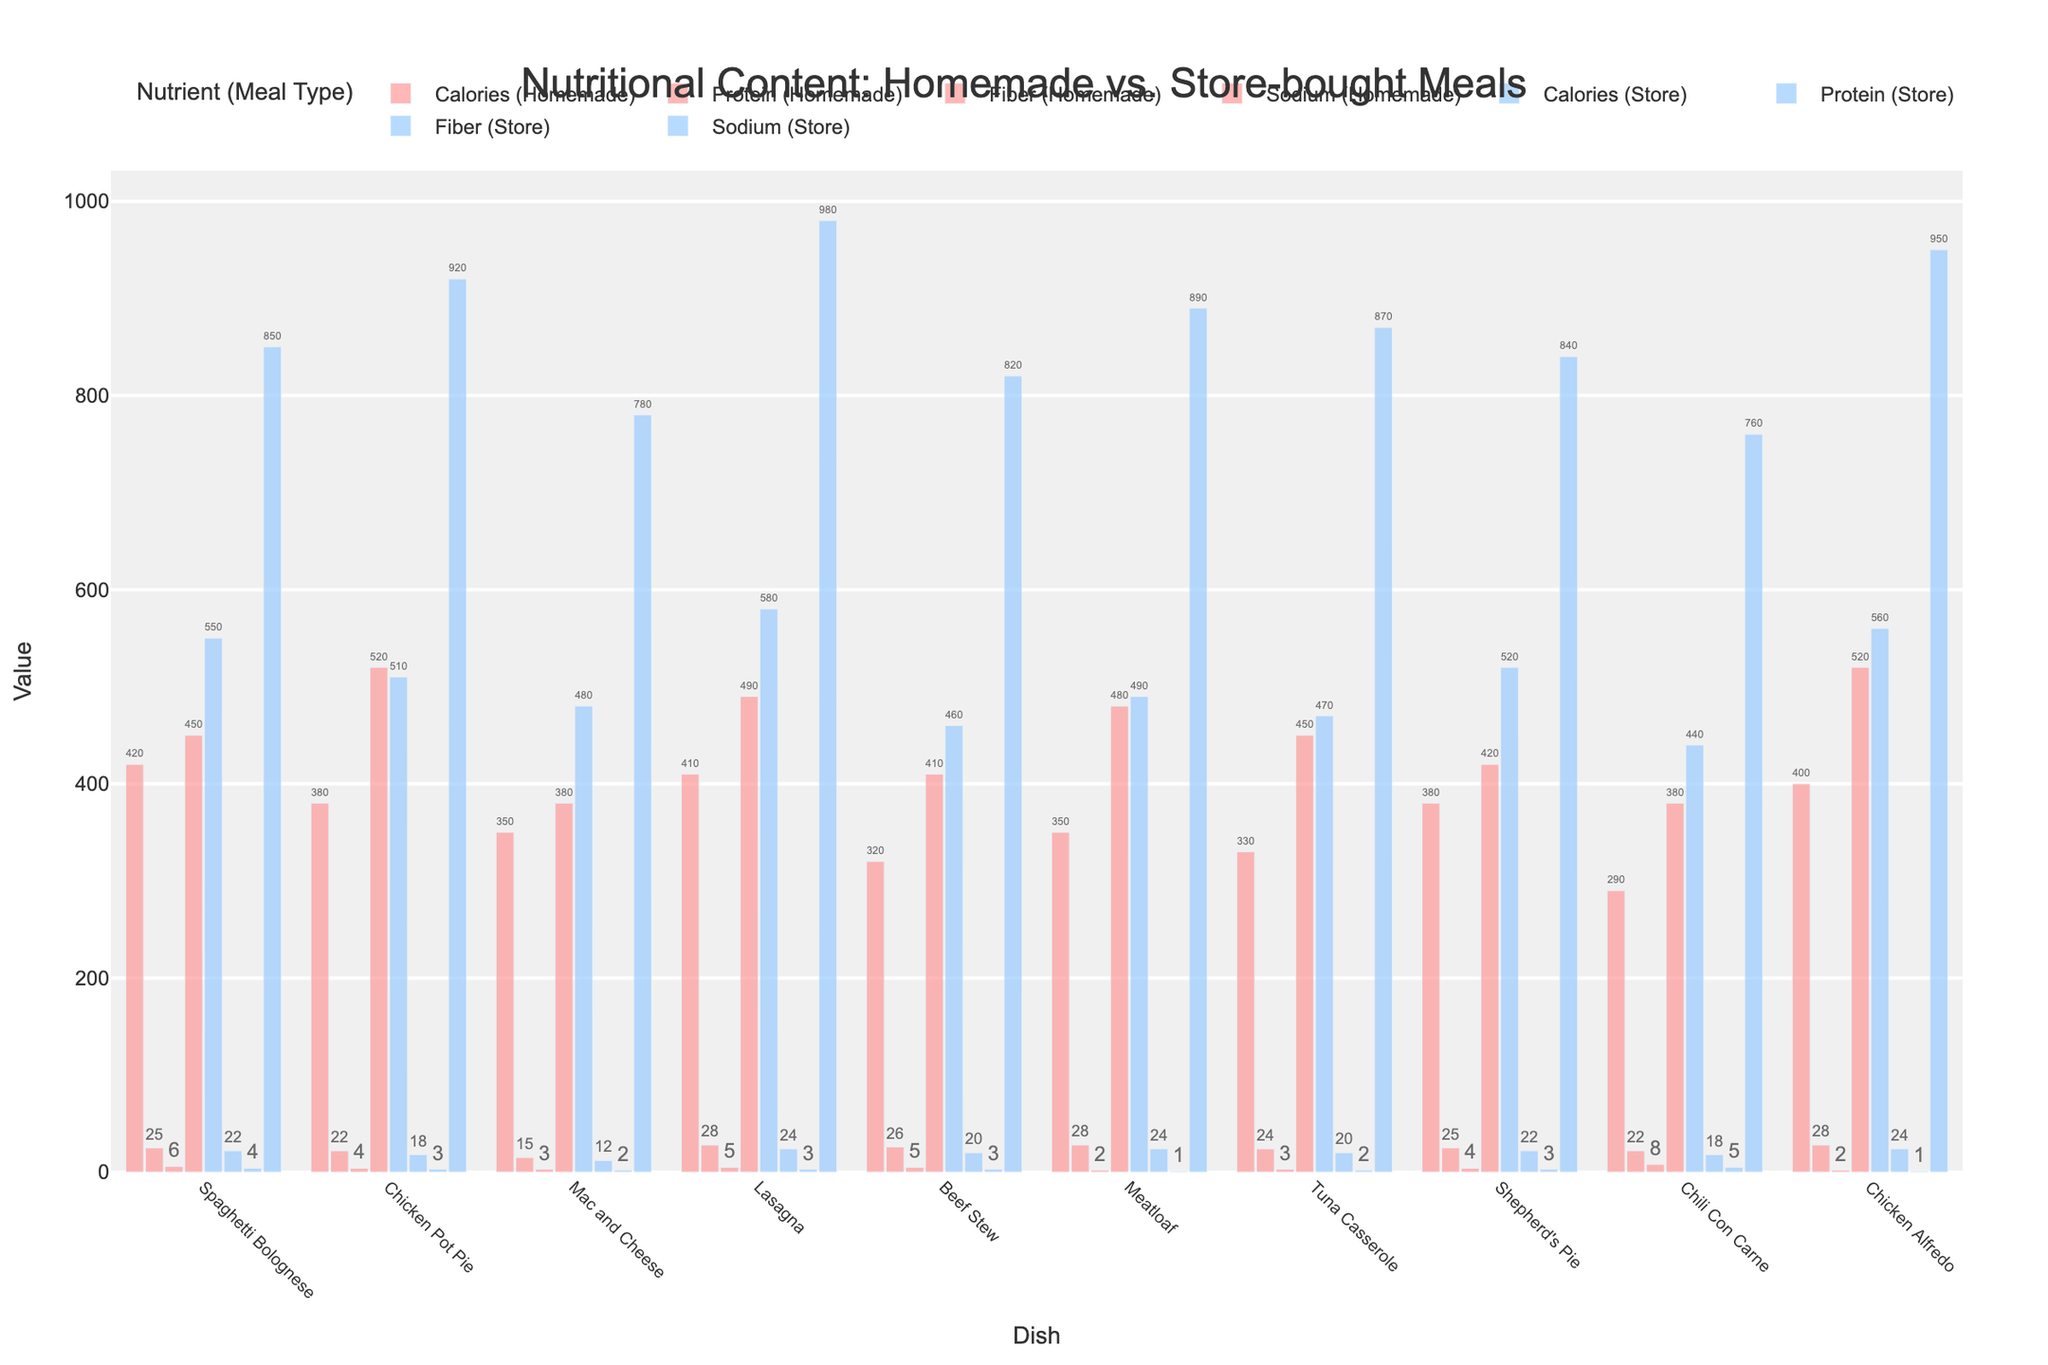What is the calorie difference between homemade and store-bought Chicken Pot Pie? Look at the bar heights for calories in Chicken Pot Pie. Homemade has 380 calories, and the store-bought has 510. Subtract 380 from 510.
Answer: 130 Which dish has the highest protein content in the homemade version? Compare the height of the protein bars for all homemade dishes. The highest bar indicates the highest protein content.
Answer: Lasagna and Chicken Alfredo How much more sodium is in store-bought Spaghetti Bolognese compared to the homemade version? Find the sodium bars for Spaghetti Bolognese. The store-bought version has 850 mg, and the homemade has 450 mg. Subtract 450 from 850.
Answer: 400 mg Is the fiber content in homemade Chili Con Carne greater or less than in the store-bought version? By how much? Check the height of the fiber bars for Chili Con Carne. Homemade has 8g, store-bought has 5g. Subtract to find the difference.
Answer: Greater by 3g What is the average fiber content for homemade meals? Add up all the fiber content for the homemade meals and divide by the number of dishes (10). (6 + 4 + 3 + 5 + 5 + 2 + 3 + 4 + 8 + 2)/10 = 42/10
Answer: 4.2g In which dish does the store-bought version have the lowest calorie count? Look for the shortest bar in the store-bought calories section.
Answer: Chili Con Carne How do the protein levels in homemade meatloaf compare to homemade Beef Stew? Compare the height of the protein bars for these two dishes.
Answer: Same, 28g Which store-bought dish has both high sodium and high calorie content? Look for bars that are high in both sodium and calories in store-bought versions.
Answer: Lasagna Considering the homemade nutrition data, which dish has the lowest calorie content and what is its fiber content? Find the shortest calorie bar for homemade dishes and then locate the corresponding fiber bar.
Answer: Chili Con Carne, 8g 